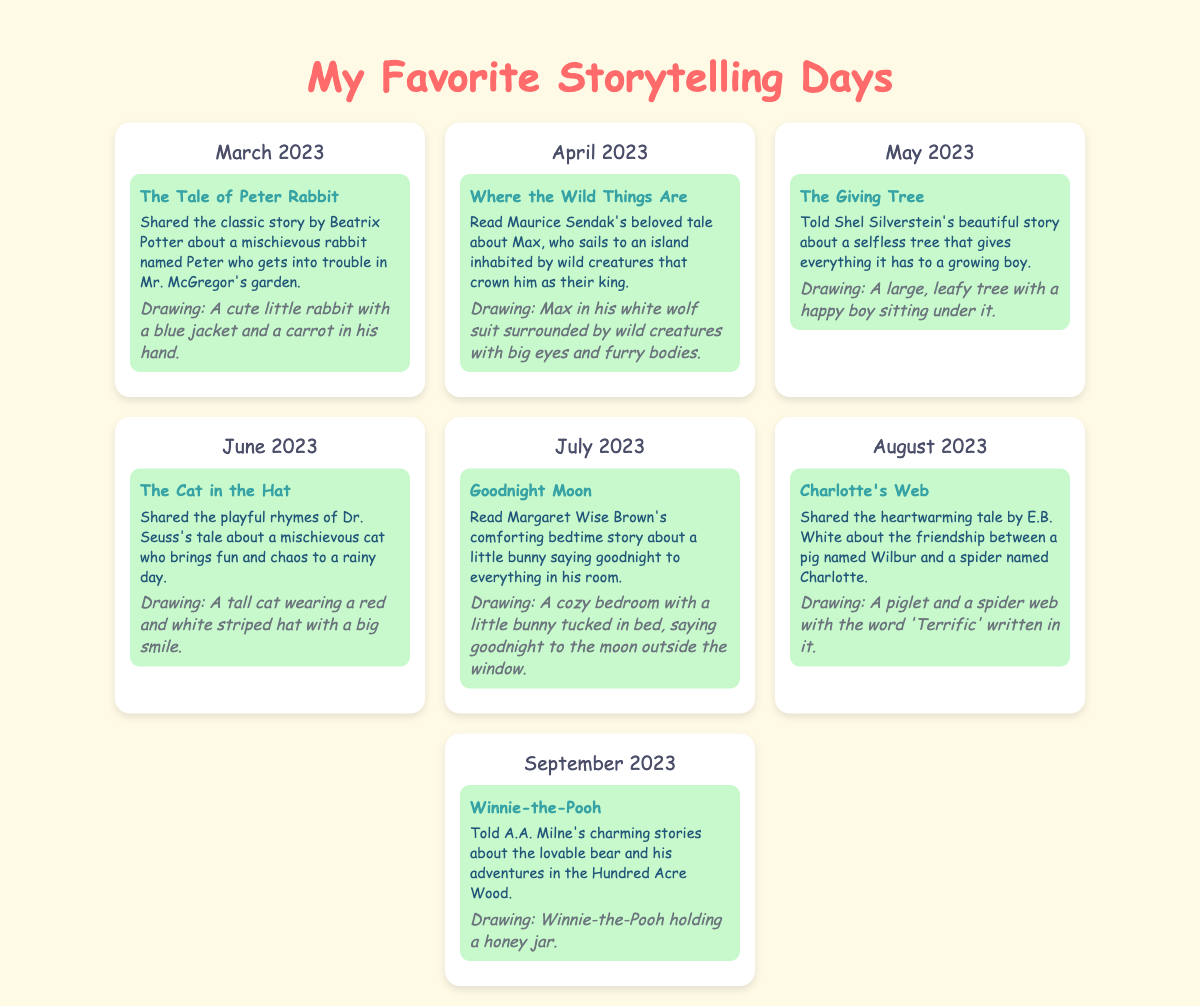What is the title of the first story shared? The first story shared in March 2023 is "The Tale of Peter Rabbit."
Answer: The Tale of Peter Rabbit How many stories are highlighted in the calendar? There are a total of seven stories highlighted across the months.
Answer: Seven Which month features "Where the Wild Things Are"? "Where the Wild Things Are" is featured in April 2023.
Answer: April 2023 What is the title of the story told in July? The story told in July 2023 is "Goodnight Moon."
Answer: Goodnight Moon Which story includes a pig named Wilbur? The story that includes a pig named Wilbur is "Charlotte's Web."
Answer: Charlotte's Web What drawing is associated with "The Cat in the Hat"? The drawing associated with "The Cat in the Hat" features a tall cat wearing a red and white striped hat with a big smile.
Answer: A tall cat wearing a red and white striped hat with a big smile Which month features the story "The Giving Tree"? "The Giving Tree" is featured in May 2023.
Answer: May 2023 